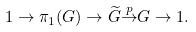<formula> <loc_0><loc_0><loc_500><loc_500>1 \to \pi _ { 1 } ( G ) \to { \widetilde { G } } { \overset { p } { \to } } G \to 1 .</formula> 